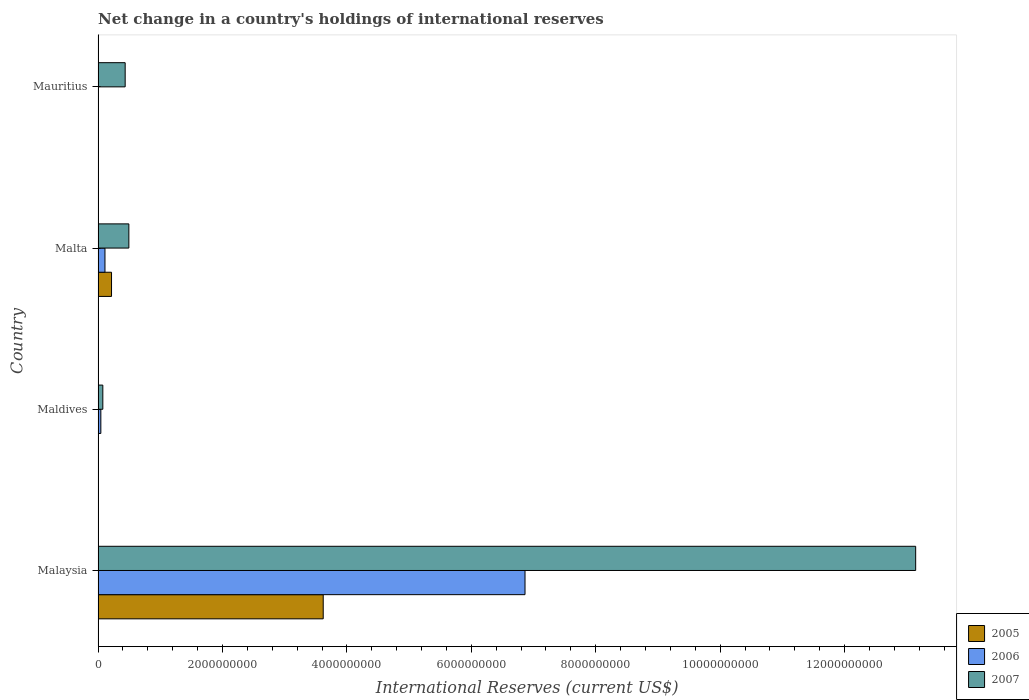How many different coloured bars are there?
Ensure brevity in your answer.  3. What is the label of the 2nd group of bars from the top?
Provide a short and direct response. Malta. What is the international reserves in 2006 in Malta?
Make the answer very short. 1.11e+08. Across all countries, what is the maximum international reserves in 2006?
Keep it short and to the point. 6.86e+09. In which country was the international reserves in 2007 maximum?
Make the answer very short. Malaysia. What is the total international reserves in 2005 in the graph?
Offer a very short reply. 3.84e+09. What is the difference between the international reserves in 2007 in Maldives and that in Mauritius?
Your answer should be very brief. -3.59e+08. What is the difference between the international reserves in 2007 in Mauritius and the international reserves in 2006 in Malta?
Provide a succinct answer. 3.25e+08. What is the average international reserves in 2005 per country?
Your answer should be very brief. 9.59e+08. What is the difference between the international reserves in 2007 and international reserves in 2005 in Malaysia?
Provide a succinct answer. 9.52e+09. In how many countries, is the international reserves in 2007 greater than 11600000000 US$?
Ensure brevity in your answer.  1. What is the ratio of the international reserves in 2007 in Malta to that in Mauritius?
Offer a very short reply. 1.14. Is the difference between the international reserves in 2007 in Malaysia and Malta greater than the difference between the international reserves in 2005 in Malaysia and Malta?
Offer a terse response. Yes. What is the difference between the highest and the second highest international reserves in 2007?
Provide a short and direct response. 1.26e+1. What is the difference between the highest and the lowest international reserves in 2006?
Offer a terse response. 6.86e+09. In how many countries, is the international reserves in 2006 greater than the average international reserves in 2006 taken over all countries?
Give a very brief answer. 1. Is the sum of the international reserves in 2007 in Malta and Mauritius greater than the maximum international reserves in 2005 across all countries?
Offer a very short reply. No. Is it the case that in every country, the sum of the international reserves in 2005 and international reserves in 2007 is greater than the international reserves in 2006?
Offer a terse response. Yes. How many countries are there in the graph?
Make the answer very short. 4. Are the values on the major ticks of X-axis written in scientific E-notation?
Provide a succinct answer. No. Does the graph contain any zero values?
Your response must be concise. Yes. Does the graph contain grids?
Your answer should be very brief. No. What is the title of the graph?
Keep it short and to the point. Net change in a country's holdings of international reserves. What is the label or title of the X-axis?
Provide a short and direct response. International Reserves (current US$). What is the International Reserves (current US$) of 2005 in Malaysia?
Ensure brevity in your answer.  3.62e+09. What is the International Reserves (current US$) in 2006 in Malaysia?
Your response must be concise. 6.86e+09. What is the International Reserves (current US$) in 2007 in Malaysia?
Provide a short and direct response. 1.31e+1. What is the International Reserves (current US$) in 2005 in Maldives?
Ensure brevity in your answer.  0. What is the International Reserves (current US$) in 2006 in Maldives?
Keep it short and to the point. 4.50e+07. What is the International Reserves (current US$) in 2007 in Maldives?
Your answer should be very brief. 7.67e+07. What is the International Reserves (current US$) in 2005 in Malta?
Keep it short and to the point. 2.17e+08. What is the International Reserves (current US$) of 2006 in Malta?
Give a very brief answer. 1.11e+08. What is the International Reserves (current US$) in 2007 in Malta?
Offer a terse response. 4.95e+08. What is the International Reserves (current US$) of 2005 in Mauritius?
Your answer should be compact. 0. What is the International Reserves (current US$) in 2006 in Mauritius?
Give a very brief answer. 0. What is the International Reserves (current US$) of 2007 in Mauritius?
Offer a terse response. 4.36e+08. Across all countries, what is the maximum International Reserves (current US$) in 2005?
Your answer should be compact. 3.62e+09. Across all countries, what is the maximum International Reserves (current US$) of 2006?
Your answer should be compact. 6.86e+09. Across all countries, what is the maximum International Reserves (current US$) in 2007?
Offer a very short reply. 1.31e+1. Across all countries, what is the minimum International Reserves (current US$) in 2006?
Give a very brief answer. 0. Across all countries, what is the minimum International Reserves (current US$) of 2007?
Your answer should be very brief. 7.67e+07. What is the total International Reserves (current US$) of 2005 in the graph?
Give a very brief answer. 3.84e+09. What is the total International Reserves (current US$) in 2006 in the graph?
Provide a succinct answer. 7.02e+09. What is the total International Reserves (current US$) of 2007 in the graph?
Provide a succinct answer. 1.42e+1. What is the difference between the International Reserves (current US$) in 2006 in Malaysia and that in Maldives?
Ensure brevity in your answer.  6.82e+09. What is the difference between the International Reserves (current US$) in 2007 in Malaysia and that in Maldives?
Give a very brief answer. 1.31e+1. What is the difference between the International Reserves (current US$) of 2005 in Malaysia and that in Malta?
Make the answer very short. 3.40e+09. What is the difference between the International Reserves (current US$) in 2006 in Malaysia and that in Malta?
Offer a very short reply. 6.75e+09. What is the difference between the International Reserves (current US$) of 2007 in Malaysia and that in Malta?
Offer a terse response. 1.26e+1. What is the difference between the International Reserves (current US$) of 2007 in Malaysia and that in Mauritius?
Offer a very short reply. 1.27e+1. What is the difference between the International Reserves (current US$) of 2006 in Maldives and that in Malta?
Give a very brief answer. -6.63e+07. What is the difference between the International Reserves (current US$) in 2007 in Maldives and that in Malta?
Make the answer very short. -4.19e+08. What is the difference between the International Reserves (current US$) in 2007 in Maldives and that in Mauritius?
Offer a terse response. -3.59e+08. What is the difference between the International Reserves (current US$) in 2007 in Malta and that in Mauritius?
Offer a terse response. 5.94e+07. What is the difference between the International Reserves (current US$) of 2005 in Malaysia and the International Reserves (current US$) of 2006 in Maldives?
Offer a very short reply. 3.57e+09. What is the difference between the International Reserves (current US$) of 2005 in Malaysia and the International Reserves (current US$) of 2007 in Maldives?
Offer a terse response. 3.54e+09. What is the difference between the International Reserves (current US$) of 2006 in Malaysia and the International Reserves (current US$) of 2007 in Maldives?
Ensure brevity in your answer.  6.79e+09. What is the difference between the International Reserves (current US$) of 2005 in Malaysia and the International Reserves (current US$) of 2006 in Malta?
Keep it short and to the point. 3.51e+09. What is the difference between the International Reserves (current US$) of 2005 in Malaysia and the International Reserves (current US$) of 2007 in Malta?
Keep it short and to the point. 3.12e+09. What is the difference between the International Reserves (current US$) in 2006 in Malaysia and the International Reserves (current US$) in 2007 in Malta?
Offer a terse response. 6.37e+09. What is the difference between the International Reserves (current US$) of 2005 in Malaysia and the International Reserves (current US$) of 2007 in Mauritius?
Give a very brief answer. 3.18e+09. What is the difference between the International Reserves (current US$) in 2006 in Malaysia and the International Reserves (current US$) in 2007 in Mauritius?
Ensure brevity in your answer.  6.43e+09. What is the difference between the International Reserves (current US$) of 2006 in Maldives and the International Reserves (current US$) of 2007 in Malta?
Provide a succinct answer. -4.50e+08. What is the difference between the International Reserves (current US$) in 2006 in Maldives and the International Reserves (current US$) in 2007 in Mauritius?
Give a very brief answer. -3.91e+08. What is the difference between the International Reserves (current US$) in 2005 in Malta and the International Reserves (current US$) in 2007 in Mauritius?
Offer a terse response. -2.19e+08. What is the difference between the International Reserves (current US$) in 2006 in Malta and the International Reserves (current US$) in 2007 in Mauritius?
Provide a short and direct response. -3.25e+08. What is the average International Reserves (current US$) of 2005 per country?
Provide a succinct answer. 9.59e+08. What is the average International Reserves (current US$) of 2006 per country?
Provide a succinct answer. 1.76e+09. What is the average International Reserves (current US$) of 2007 per country?
Your answer should be compact. 3.54e+09. What is the difference between the International Reserves (current US$) of 2005 and International Reserves (current US$) of 2006 in Malaysia?
Provide a succinct answer. -3.24e+09. What is the difference between the International Reserves (current US$) in 2005 and International Reserves (current US$) in 2007 in Malaysia?
Give a very brief answer. -9.52e+09. What is the difference between the International Reserves (current US$) of 2006 and International Reserves (current US$) of 2007 in Malaysia?
Give a very brief answer. -6.28e+09. What is the difference between the International Reserves (current US$) in 2006 and International Reserves (current US$) in 2007 in Maldives?
Make the answer very short. -3.17e+07. What is the difference between the International Reserves (current US$) in 2005 and International Reserves (current US$) in 2006 in Malta?
Offer a terse response. 1.05e+08. What is the difference between the International Reserves (current US$) in 2005 and International Reserves (current US$) in 2007 in Malta?
Provide a short and direct response. -2.79e+08. What is the difference between the International Reserves (current US$) in 2006 and International Reserves (current US$) in 2007 in Malta?
Keep it short and to the point. -3.84e+08. What is the ratio of the International Reserves (current US$) of 2006 in Malaysia to that in Maldives?
Your answer should be compact. 152.62. What is the ratio of the International Reserves (current US$) of 2007 in Malaysia to that in Maldives?
Your answer should be very brief. 171.34. What is the ratio of the International Reserves (current US$) of 2005 in Malaysia to that in Malta?
Provide a short and direct response. 16.7. What is the ratio of the International Reserves (current US$) in 2006 in Malaysia to that in Malta?
Your response must be concise. 61.66. What is the ratio of the International Reserves (current US$) of 2007 in Malaysia to that in Malta?
Your answer should be compact. 26.53. What is the ratio of the International Reserves (current US$) in 2007 in Malaysia to that in Mauritius?
Offer a terse response. 30.14. What is the ratio of the International Reserves (current US$) of 2006 in Maldives to that in Malta?
Your answer should be compact. 0.4. What is the ratio of the International Reserves (current US$) in 2007 in Maldives to that in Malta?
Give a very brief answer. 0.15. What is the ratio of the International Reserves (current US$) in 2007 in Maldives to that in Mauritius?
Provide a short and direct response. 0.18. What is the ratio of the International Reserves (current US$) in 2007 in Malta to that in Mauritius?
Your answer should be very brief. 1.14. What is the difference between the highest and the second highest International Reserves (current US$) of 2006?
Keep it short and to the point. 6.75e+09. What is the difference between the highest and the second highest International Reserves (current US$) in 2007?
Keep it short and to the point. 1.26e+1. What is the difference between the highest and the lowest International Reserves (current US$) in 2005?
Your answer should be very brief. 3.62e+09. What is the difference between the highest and the lowest International Reserves (current US$) in 2006?
Your response must be concise. 6.86e+09. What is the difference between the highest and the lowest International Reserves (current US$) in 2007?
Give a very brief answer. 1.31e+1. 